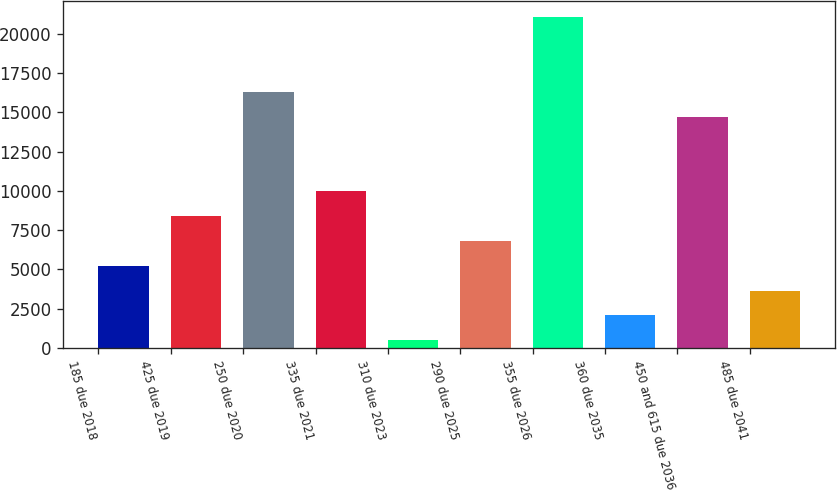Convert chart. <chart><loc_0><loc_0><loc_500><loc_500><bar_chart><fcel>185 due 2018<fcel>425 due 2019<fcel>250 due 2020<fcel>335 due 2021<fcel>310 due 2023<fcel>290 due 2025<fcel>355 due 2026<fcel>360 due 2035<fcel>450 and 615 due 2036<fcel>485 due 2041<nl><fcel>5238.8<fcel>8398<fcel>16296<fcel>9977.6<fcel>500<fcel>6818.4<fcel>21034.8<fcel>2079.6<fcel>14716.4<fcel>3659.2<nl></chart> 